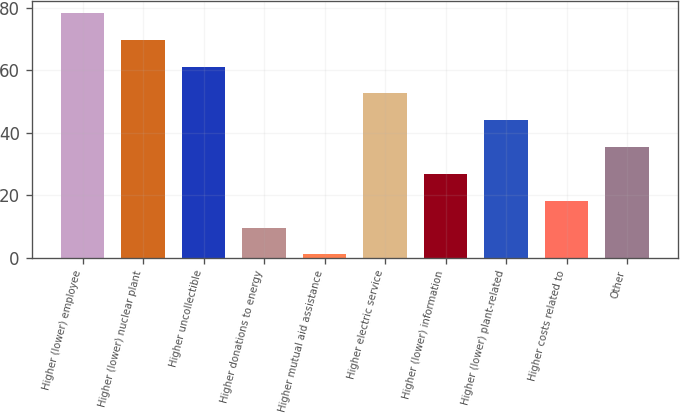<chart> <loc_0><loc_0><loc_500><loc_500><bar_chart><fcel>Higher (lower) employee<fcel>Higher (lower) nuclear plant<fcel>Higher uncollectible<fcel>Higher donations to energy<fcel>Higher mutual aid assistance<fcel>Higher electric service<fcel>Higher (lower) information<fcel>Higher (lower) plant-related<fcel>Higher costs related to<fcel>Other<nl><fcel>78.4<fcel>69.8<fcel>61.2<fcel>9.6<fcel>1<fcel>52.6<fcel>26.8<fcel>44<fcel>18.2<fcel>35.4<nl></chart> 